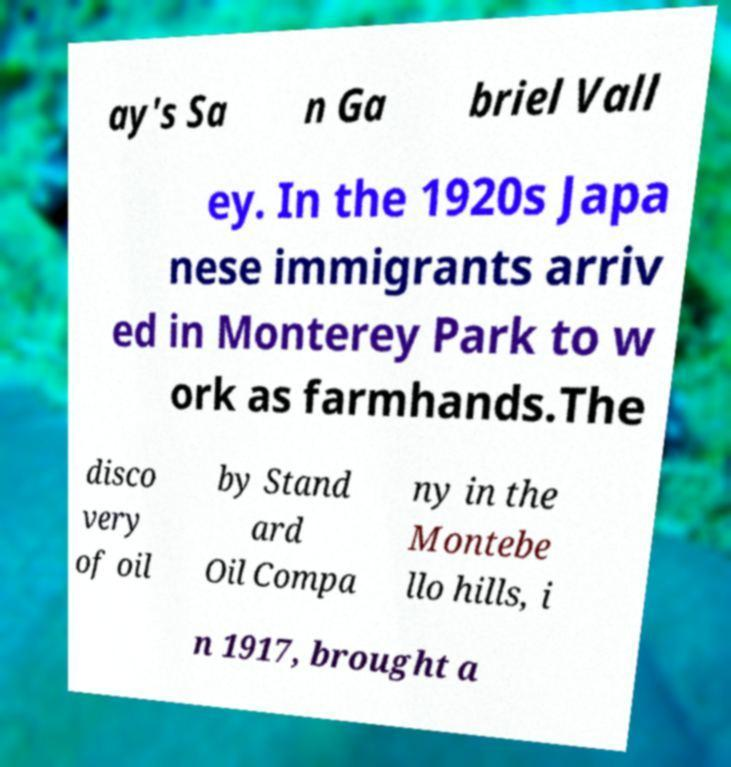Please read and relay the text visible in this image. What does it say? ay's Sa n Ga briel Vall ey. In the 1920s Japa nese immigrants arriv ed in Monterey Park to w ork as farmhands.The disco very of oil by Stand ard Oil Compa ny in the Montebe llo hills, i n 1917, brought a 